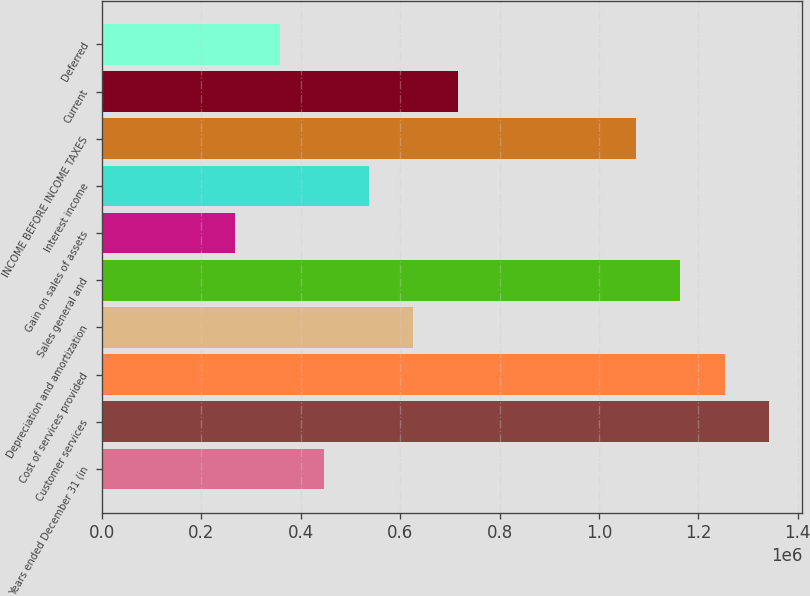<chart> <loc_0><loc_0><loc_500><loc_500><bar_chart><fcel>Years ended December 31 (in<fcel>Customer services<fcel>Cost of services provided<fcel>Depreciation and amortization<fcel>Sales general and<fcel>Gain on sales of assets<fcel>Interest income<fcel>INCOME BEFORE INCOME TAXES<fcel>Current<fcel>Deferred<nl><fcel>447460<fcel>1.34238e+06<fcel>1.25289e+06<fcel>626444<fcel>1.1634e+06<fcel>268476<fcel>536952<fcel>1.0739e+06<fcel>715936<fcel>357968<nl></chart> 